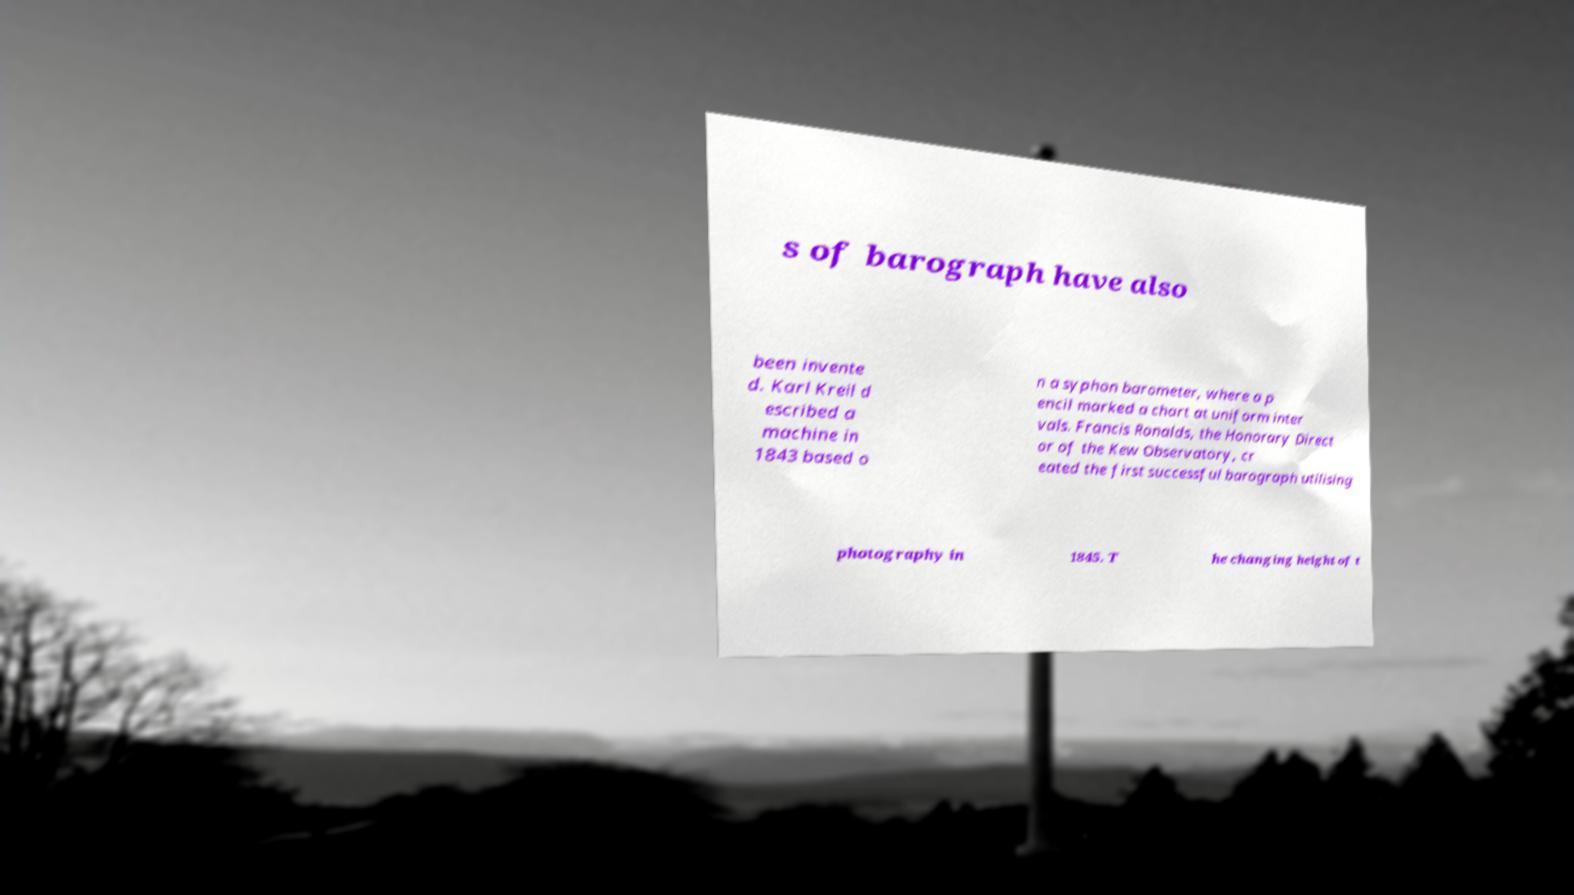Could you assist in decoding the text presented in this image and type it out clearly? s of barograph have also been invente d. Karl Kreil d escribed a machine in 1843 based o n a syphon barometer, where a p encil marked a chart at uniform inter vals. Francis Ronalds, the Honorary Direct or of the Kew Observatory, cr eated the first successful barograph utilising photography in 1845. T he changing height of t 